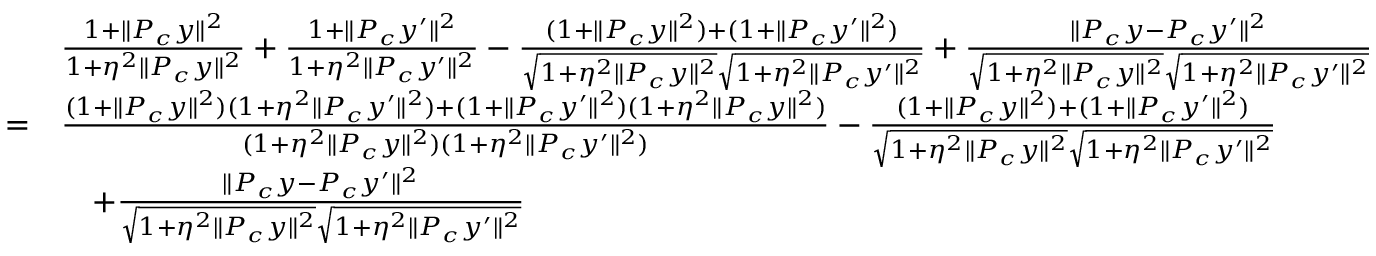Convert formula to latex. <formula><loc_0><loc_0><loc_500><loc_500>\begin{array} { r l } & { \frac { 1 + \| P _ { c } y \| ^ { 2 } } { 1 + \eta ^ { 2 } \| P _ { c } y \| ^ { 2 } } + \frac { 1 + \| P _ { c } y ^ { \prime } \| ^ { 2 } } { 1 + \eta ^ { 2 } \| P _ { c } y ^ { \prime } \| ^ { 2 } } - \frac { ( 1 + \| P _ { c } y \| ^ { 2 } ) + ( 1 + \| P _ { c } y ^ { \prime } \| ^ { 2 } ) } { \sqrt { 1 + \eta ^ { 2 } \| P _ { c } y \| ^ { 2 } } \sqrt { 1 + \eta ^ { 2 } \| P _ { c } y ^ { \prime } \| ^ { 2 } } } + \frac { \| P _ { c } y - P _ { c } y ^ { \prime } \| ^ { 2 } } { \sqrt { 1 + \eta ^ { 2 } \| P _ { c } y \| ^ { 2 } } \sqrt { 1 + \eta ^ { 2 } \| P _ { c } y ^ { \prime } \| ^ { 2 } } } } \\ { = } & { \frac { ( 1 + \| P _ { c } y \| ^ { 2 } ) ( 1 + \eta ^ { 2 } \| P _ { c } y ^ { \prime } \| ^ { 2 } ) + ( 1 + \| P _ { c } y ^ { \prime } \| ^ { 2 } ) ( 1 + \eta ^ { 2 } \| P _ { c } y \| ^ { 2 } ) } { ( 1 + \eta ^ { 2 } \| P _ { c } y \| ^ { 2 } ) ( 1 + \eta ^ { 2 } \| P _ { c } y ^ { \prime } \| ^ { 2 } ) } - \frac { ( 1 + \| P _ { c } y \| ^ { 2 } ) + ( 1 + \| P _ { c } y ^ { \prime } \| ^ { 2 } ) } { \sqrt { 1 + \eta ^ { 2 } \| P _ { c } y \| ^ { 2 } } \sqrt { 1 + \eta ^ { 2 } \| P _ { c } y ^ { \prime } \| ^ { 2 } } } } \\ & { \quad + \frac { \| P _ { c } y - P _ { c } y ^ { \prime } \| ^ { 2 } } { \sqrt { 1 + \eta ^ { 2 } \| P _ { c } y \| ^ { 2 } } \sqrt { 1 + \eta ^ { 2 } \| P _ { c } y ^ { \prime } \| ^ { 2 } } } } \end{array}</formula> 